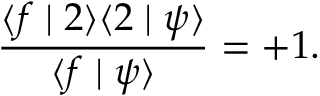<formula> <loc_0><loc_0><loc_500><loc_500>\frac { \langle f | 2 \rangle \langle 2 | \psi \rangle } { \langle f | \psi \rangle } = + 1 .</formula> 